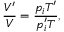Convert formula to latex. <formula><loc_0><loc_0><loc_500><loc_500>\frac { V ^ { \prime } } { V } = \frac { p _ { i } T ^ { \prime } } { p _ { i } ^ { \prime } T } ,</formula> 